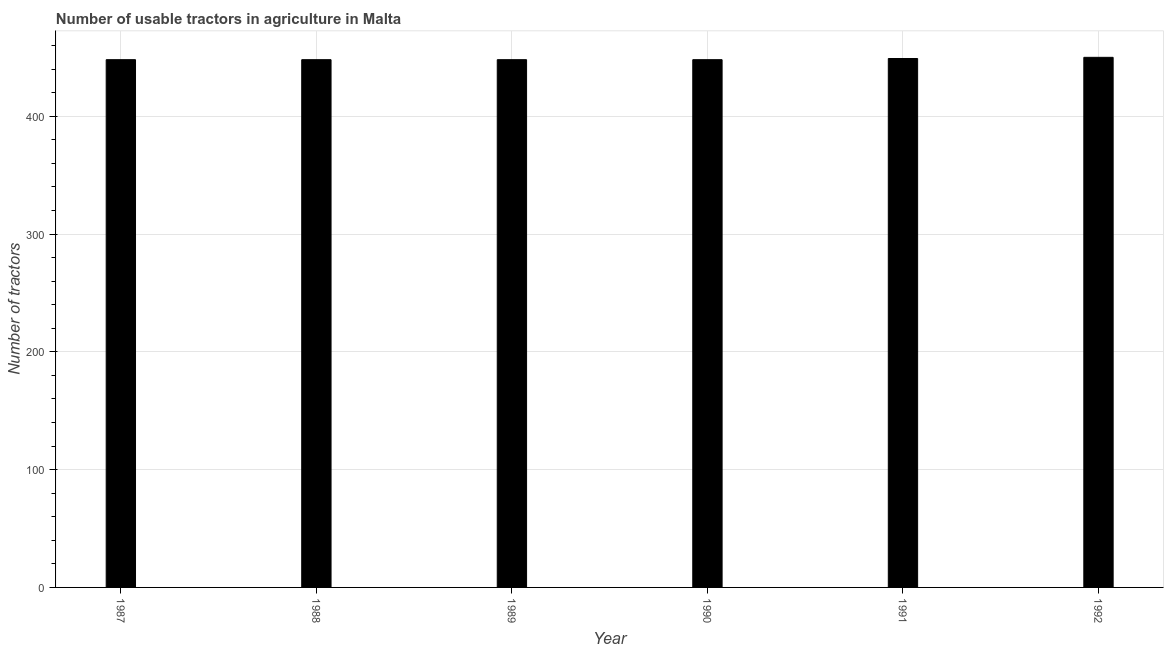What is the title of the graph?
Offer a terse response. Number of usable tractors in agriculture in Malta. What is the label or title of the Y-axis?
Offer a very short reply. Number of tractors. What is the number of tractors in 1992?
Offer a terse response. 450. Across all years, what is the maximum number of tractors?
Your answer should be very brief. 450. Across all years, what is the minimum number of tractors?
Your answer should be compact. 448. What is the sum of the number of tractors?
Give a very brief answer. 2691. What is the difference between the number of tractors in 1988 and 1990?
Ensure brevity in your answer.  0. What is the average number of tractors per year?
Provide a short and direct response. 448. What is the median number of tractors?
Your answer should be very brief. 448. Do a majority of the years between 1987 and 1990 (inclusive) have number of tractors greater than 120 ?
Provide a short and direct response. Yes. What is the ratio of the number of tractors in 1990 to that in 1991?
Make the answer very short. 1. Is the number of tractors in 1988 less than that in 1992?
Your answer should be very brief. Yes. What is the difference between the highest and the second highest number of tractors?
Your answer should be very brief. 1. What is the difference between the highest and the lowest number of tractors?
Your response must be concise. 2. How many years are there in the graph?
Provide a succinct answer. 6. What is the difference between two consecutive major ticks on the Y-axis?
Your answer should be very brief. 100. Are the values on the major ticks of Y-axis written in scientific E-notation?
Ensure brevity in your answer.  No. What is the Number of tractors in 1987?
Your answer should be very brief. 448. What is the Number of tractors in 1988?
Your response must be concise. 448. What is the Number of tractors of 1989?
Offer a terse response. 448. What is the Number of tractors in 1990?
Make the answer very short. 448. What is the Number of tractors of 1991?
Your answer should be very brief. 449. What is the Number of tractors in 1992?
Ensure brevity in your answer.  450. What is the difference between the Number of tractors in 1987 and 1989?
Keep it short and to the point. 0. What is the difference between the Number of tractors in 1988 and 1989?
Provide a succinct answer. 0. What is the difference between the Number of tractors in 1988 and 1991?
Ensure brevity in your answer.  -1. What is the ratio of the Number of tractors in 1987 to that in 1990?
Ensure brevity in your answer.  1. What is the ratio of the Number of tractors in 1987 to that in 1991?
Your answer should be compact. 1. What is the ratio of the Number of tractors in 1987 to that in 1992?
Ensure brevity in your answer.  1. What is the ratio of the Number of tractors in 1988 to that in 1990?
Provide a succinct answer. 1. What is the ratio of the Number of tractors in 1988 to that in 1992?
Give a very brief answer. 1. What is the ratio of the Number of tractors in 1989 to that in 1990?
Your answer should be very brief. 1. What is the ratio of the Number of tractors in 1989 to that in 1991?
Your answer should be compact. 1. 